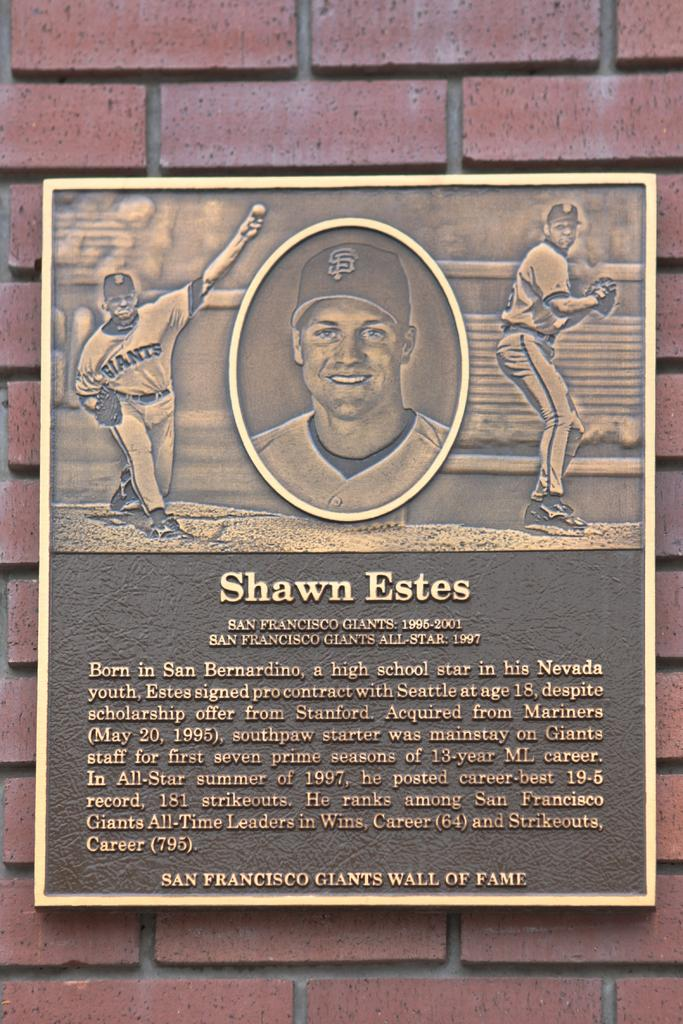<image>
Provide a brief description of the given image. Plaque on the side of a building with the name of Shawn Estes on it. 